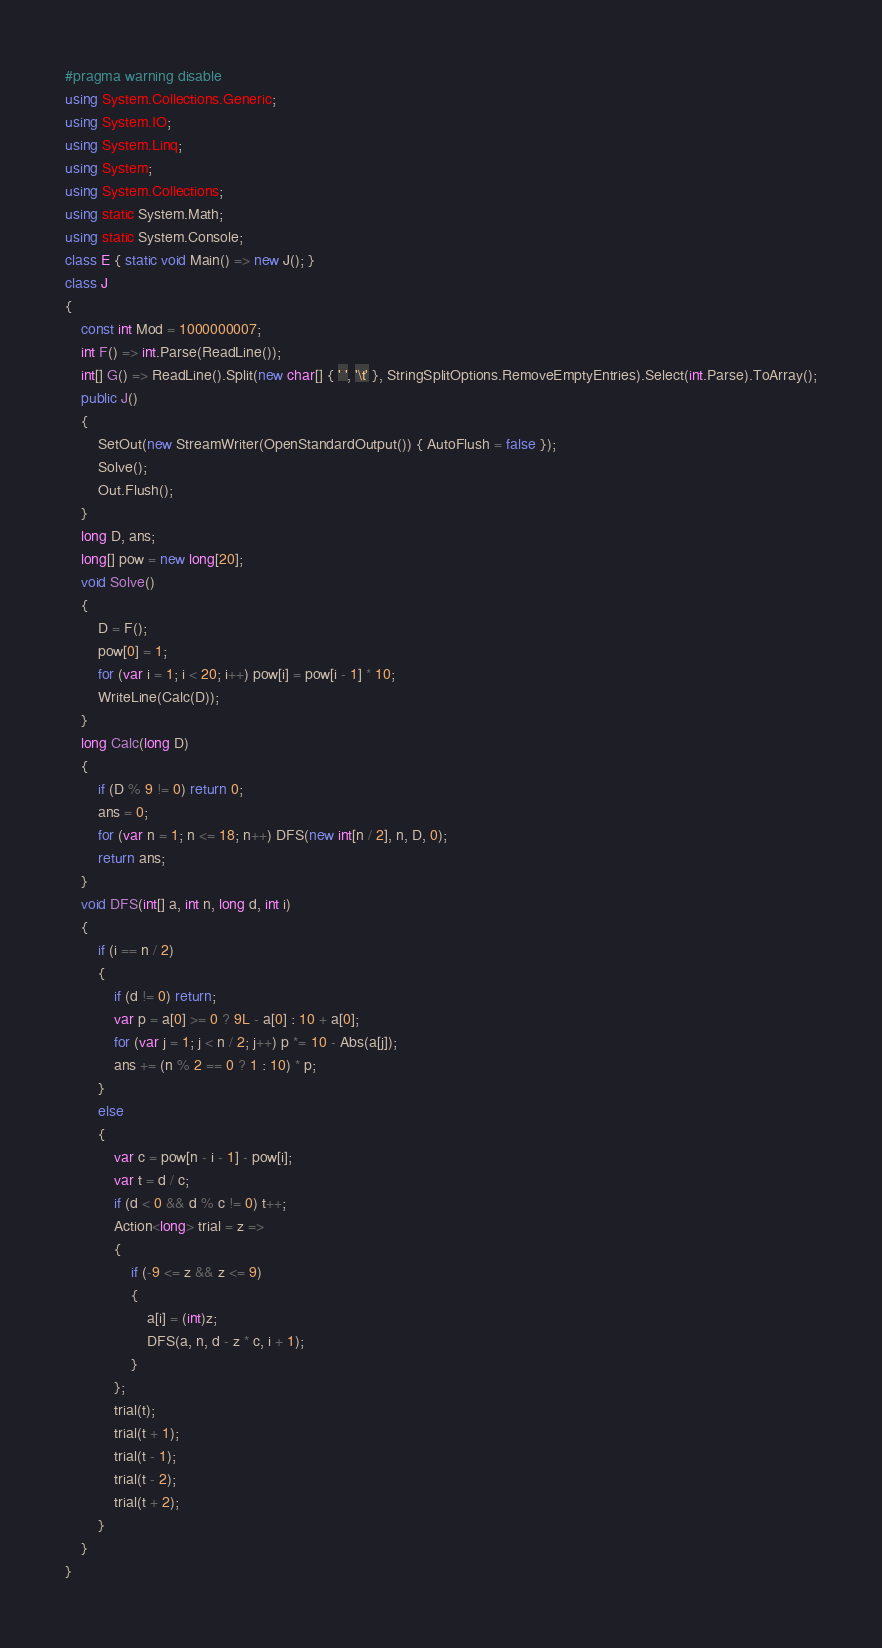<code> <loc_0><loc_0><loc_500><loc_500><_C#_>#pragma warning disable
using System.Collections.Generic;
using System.IO;
using System.Linq;
using System;
using System.Collections;
using static System.Math;
using static System.Console;
class E { static void Main() => new J(); }
class J
{
	const int Mod = 1000000007;
	int F() => int.Parse(ReadLine());
	int[] G() => ReadLine().Split(new char[] { ' ', '\t' }, StringSplitOptions.RemoveEmptyEntries).Select(int.Parse).ToArray();
	public J()
	{
		SetOut(new StreamWriter(OpenStandardOutput()) { AutoFlush = false });
		Solve();
		Out.Flush();
	}
	long D, ans;
	long[] pow = new long[20];
	void Solve()
	{
		D = F();
		pow[0] = 1;
		for (var i = 1; i < 20; i++) pow[i] = pow[i - 1] * 10;
		WriteLine(Calc(D));
	}
	long Calc(long D)
	{
		if (D % 9 != 0) return 0;
		ans = 0;
		for (var n = 1; n <= 18; n++) DFS(new int[n / 2], n, D, 0);
		return ans;
	}
	void DFS(int[] a, int n, long d, int i)
	{
		if (i == n / 2)
		{
			if (d != 0) return;
			var p = a[0] >= 0 ? 9L - a[0] : 10 + a[0];
			for (var j = 1; j < n / 2; j++) p *= 10 - Abs(a[j]);
			ans += (n % 2 == 0 ? 1 : 10) * p;
		}
		else
		{
			var c = pow[n - i - 1] - pow[i];
			var t = d / c;
			if (d < 0 && d % c != 0) t++;
			Action<long> trial = z =>
			{
				if (-9 <= z && z <= 9)
				{
					a[i] = (int)z;
					DFS(a, n, d - z * c, i + 1);
				}
			};
			trial(t);
			trial(t + 1);
			trial(t - 1);
			trial(t - 2);
			trial(t + 2);
		}
	}
}</code> 